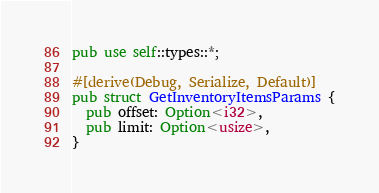<code> <loc_0><loc_0><loc_500><loc_500><_Rust_>pub use self::types::*;

#[derive(Debug, Serialize, Default)]
pub struct GetInventoryItemsParams {
  pub offset: Option<i32>,
  pub limit: Option<usize>,
}
</code> 